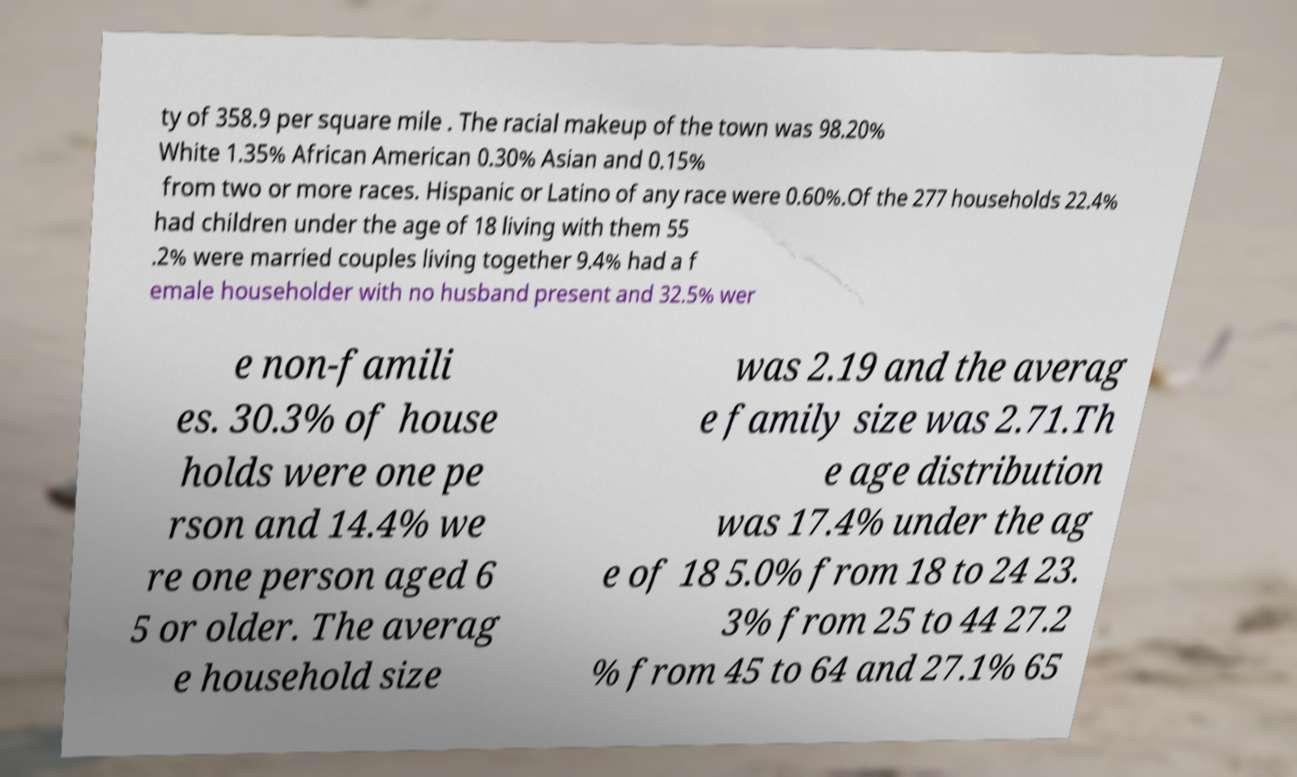I need the written content from this picture converted into text. Can you do that? ty of 358.9 per square mile . The racial makeup of the town was 98.20% White 1.35% African American 0.30% Asian and 0.15% from two or more races. Hispanic or Latino of any race were 0.60%.Of the 277 households 22.4% had children under the age of 18 living with them 55 .2% were married couples living together 9.4% had a f emale householder with no husband present and 32.5% wer e non-famili es. 30.3% of house holds were one pe rson and 14.4% we re one person aged 6 5 or older. The averag e household size was 2.19 and the averag e family size was 2.71.Th e age distribution was 17.4% under the ag e of 18 5.0% from 18 to 24 23. 3% from 25 to 44 27.2 % from 45 to 64 and 27.1% 65 